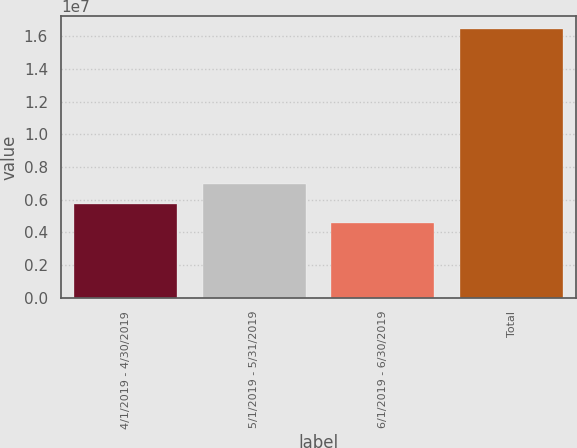Convert chart to OTSL. <chart><loc_0><loc_0><loc_500><loc_500><bar_chart><fcel>4/1/2019 - 4/30/2019<fcel>5/1/2019 - 5/31/2019<fcel>6/1/2019 - 6/30/2019<fcel>Total<nl><fcel>5.75402e+06<fcel>6.94047e+06<fcel>4.56757e+06<fcel>1.64321e+07<nl></chart> 